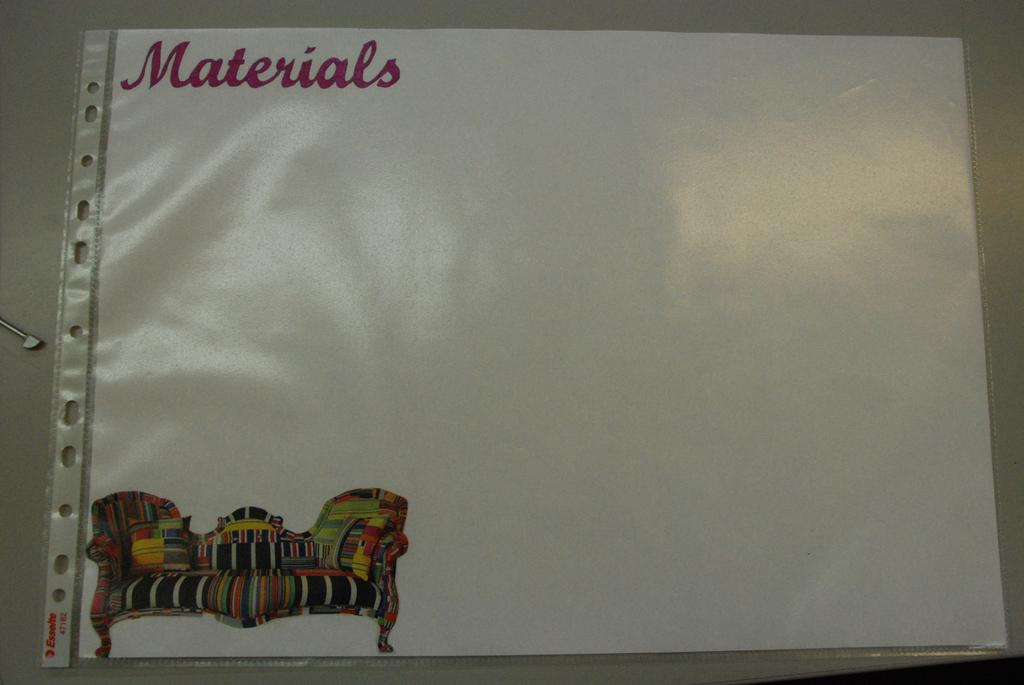Provide a one-sentence caption for the provided image. A laminated piece of paper with a picture of a sofa on it reads, "Materials". 